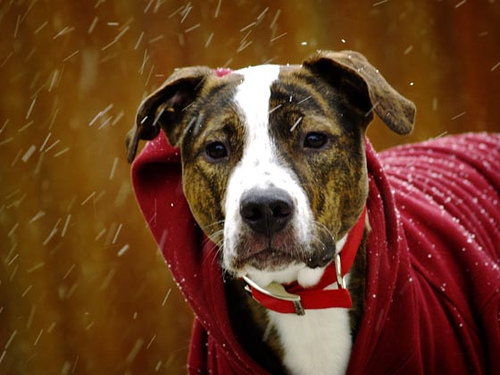<image>
Is there a collar on the dog? Yes. Looking at the image, I can see the collar is positioned on top of the dog, with the dog providing support. Where is the dog in relation to the red shirt? Is it under the red shirt? Yes. The dog is positioned underneath the red shirt, with the red shirt above it in the vertical space. Is there a snow behind the collar? Yes. From this viewpoint, the snow is positioned behind the collar, with the collar partially or fully occluding the snow. 